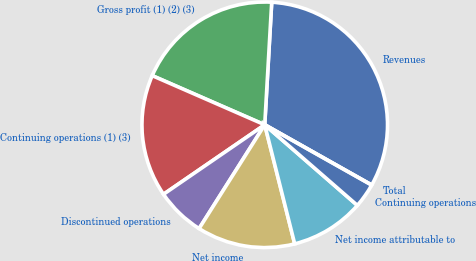Convert chart to OTSL. <chart><loc_0><loc_0><loc_500><loc_500><pie_chart><fcel>Revenues<fcel>Gross profit (1) (2) (3)<fcel>Continuing operations (1) (3)<fcel>Discontinued operations<fcel>Net income<fcel>Net income attributable to<fcel>Continuing operations<fcel>Total<nl><fcel>32.26%<fcel>19.35%<fcel>16.13%<fcel>6.45%<fcel>12.9%<fcel>9.68%<fcel>3.23%<fcel>0.0%<nl></chart> 